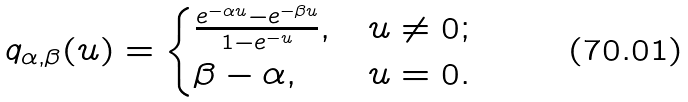<formula> <loc_0><loc_0><loc_500><loc_500>q _ { \alpha , \beta } ( u ) = \begin{cases} \frac { e ^ { - \alpha u } - e ^ { - \beta u } } { 1 - e ^ { - u } } , & u \ne 0 ; \\ \beta - \alpha , & u = 0 . \end{cases}</formula> 